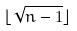<formula> <loc_0><loc_0><loc_500><loc_500>\lfloor \sqrt { n - 1 } \rfloor</formula> 